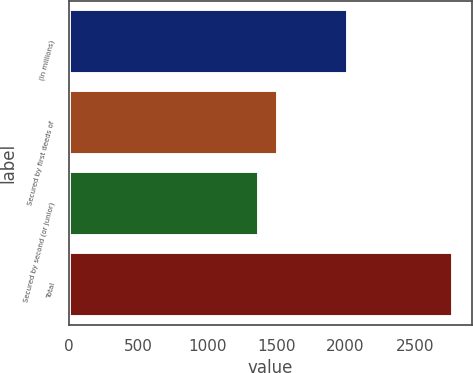<chart> <loc_0><loc_0><loc_500><loc_500><bar_chart><fcel>(In millions)<fcel>Secured by first deeds of<fcel>Secured by second (or junior)<fcel>Total<nl><fcel>2017<fcel>1511.6<fcel>1371<fcel>2777<nl></chart> 